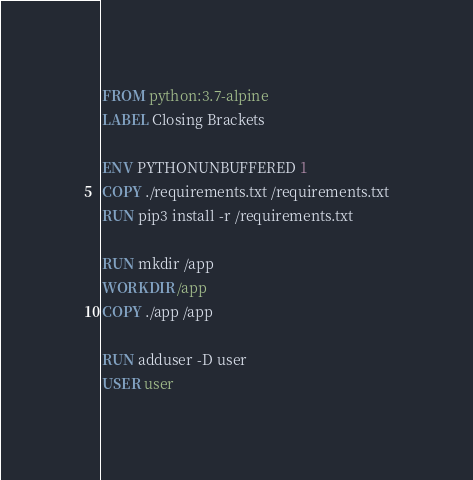<code> <loc_0><loc_0><loc_500><loc_500><_Dockerfile_>FROM python:3.7-alpine
LABEL Closing Brackets

ENV PYTHONUNBUFFERED 1
COPY ./requirements.txt /requirements.txt
RUN pip3 install -r /requirements.txt

RUN mkdir /app
WORKDIR /app
COPY ./app /app

RUN adduser -D user
USER user</code> 